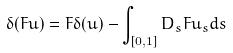<formula> <loc_0><loc_0><loc_500><loc_500>\delta ( F u ) = F \delta ( u ) - \int _ { [ 0 , 1 ] } D _ { s } F u _ { s } d s</formula> 